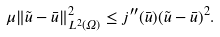<formula> <loc_0><loc_0><loc_500><loc_500>\mu \| \tilde { u } - \bar { u } \| _ { L ^ { 2 } ( \Omega ) } ^ { 2 } \leq j ^ { \prime \prime } ( \bar { u } ) ( \tilde { u } - \bar { u } ) ^ { 2 } .</formula> 